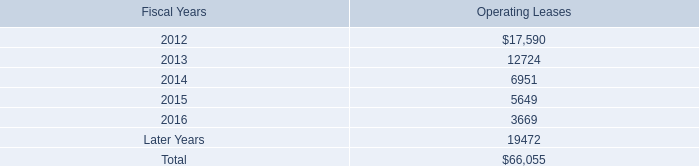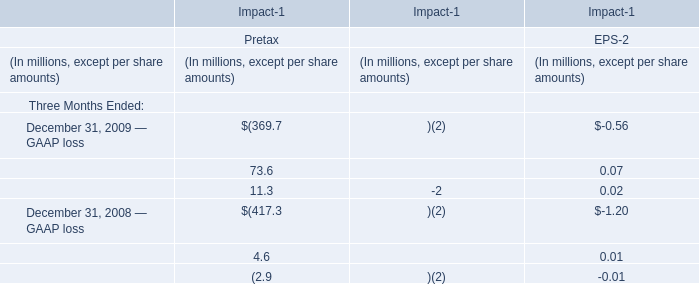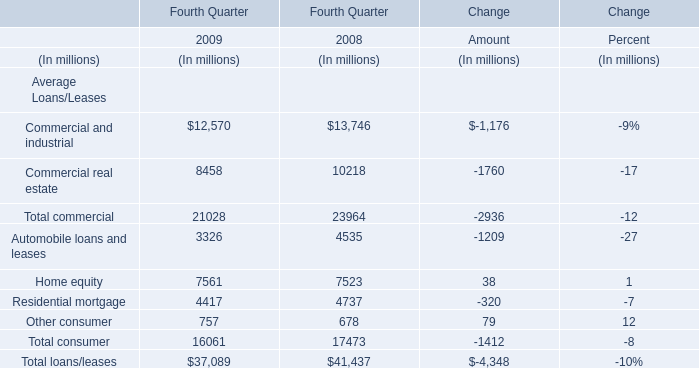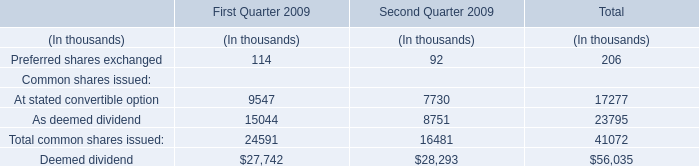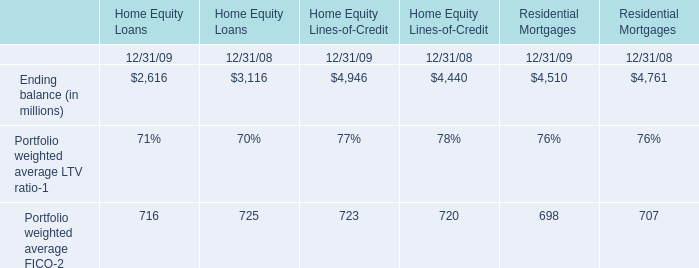In the year with lower Commercial real estate in Fourth Quarter , what's the growing rate of Automobile loans and leases in Fourth Quarter? 
Computations: ((3326 - 4535) / 4535)
Answer: -0.26659. 